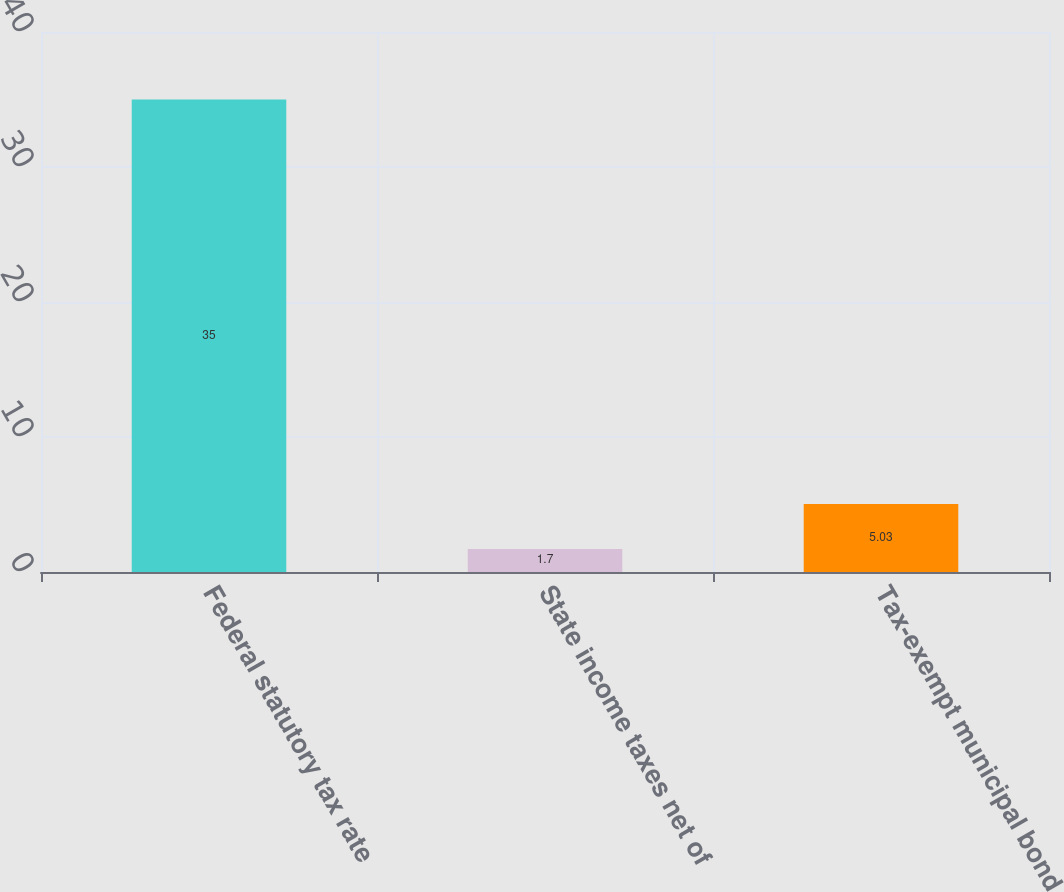Convert chart. <chart><loc_0><loc_0><loc_500><loc_500><bar_chart><fcel>Federal statutory tax rate<fcel>State income taxes net of<fcel>Tax-exempt municipal bond<nl><fcel>35<fcel>1.7<fcel>5.03<nl></chart> 